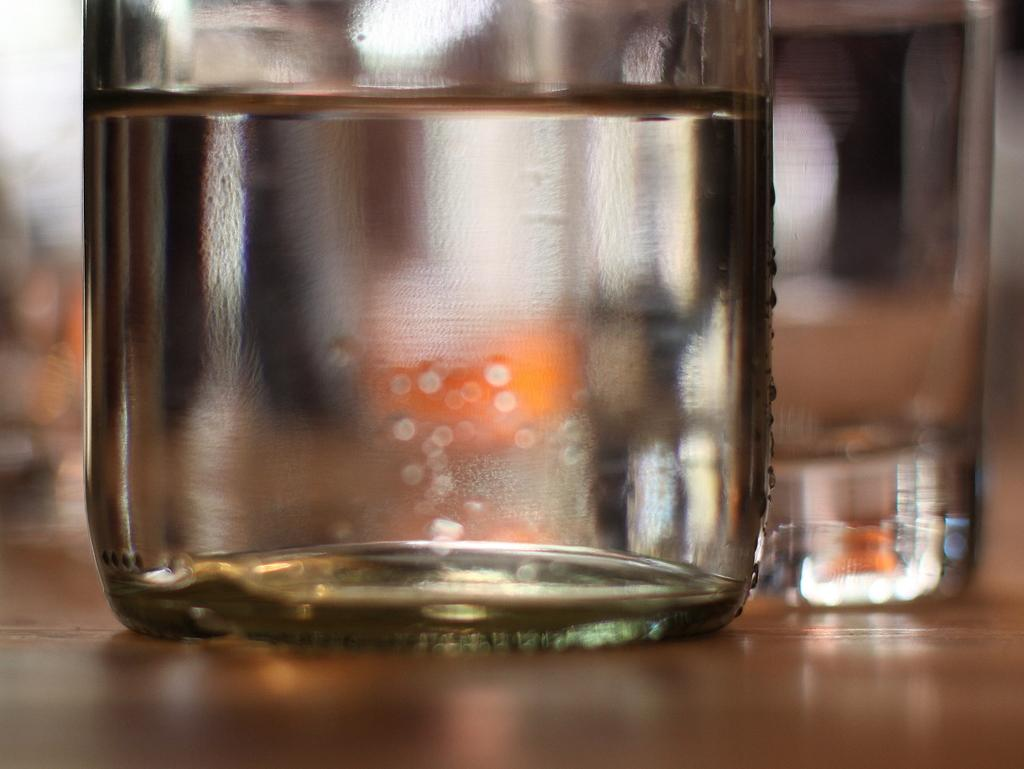How many glasses can be seen in the image? There are two glasses in the image. What is inside the glasses? The glasses are filled with liquid. What type of trade is being conducted with the glasses in the image? There is no indication of any trade being conducted in the image; it simply shows two glasses filled with liquid. 